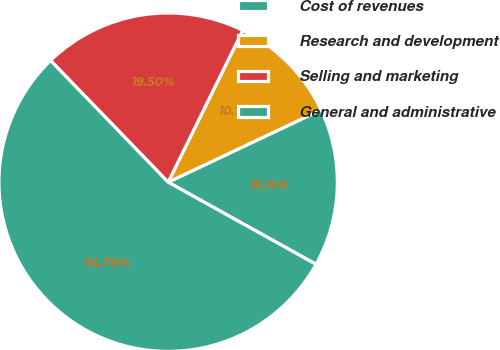Convert chart to OTSL. <chart><loc_0><loc_0><loc_500><loc_500><pie_chart><fcel>Cost of revenues<fcel>Research and development<fcel>Selling and marketing<fcel>General and administrative<nl><fcel>15.1%<fcel>10.7%<fcel>19.5%<fcel>54.7%<nl></chart> 